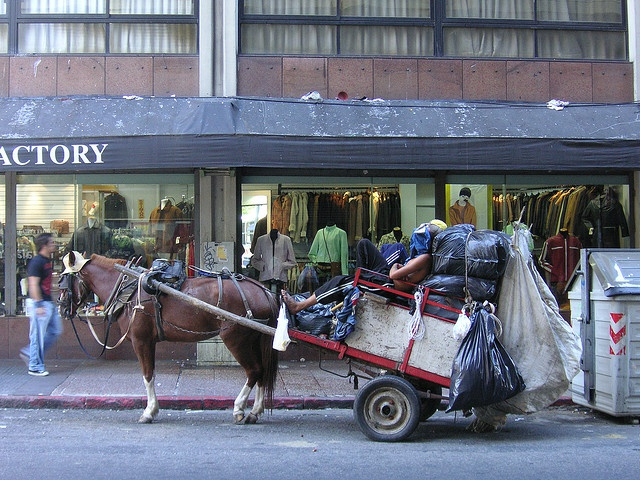Describe the objects in this image and their specific colors. I can see horse in white, black, gray, and darkgray tones, people in white, black, navy, maroon, and gray tones, and people in white, lightblue, gray, and darkgray tones in this image. 